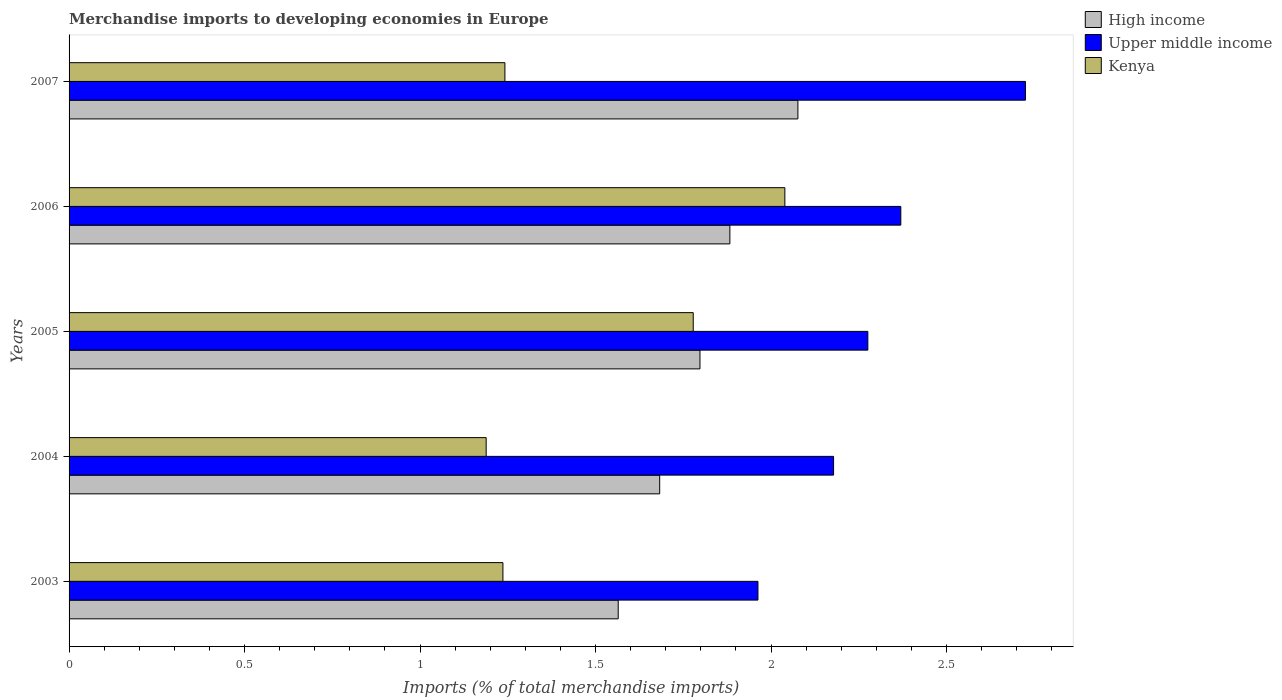How many groups of bars are there?
Offer a terse response. 5. What is the label of the 2nd group of bars from the top?
Your answer should be compact. 2006. In how many cases, is the number of bars for a given year not equal to the number of legend labels?
Make the answer very short. 0. What is the percentage total merchandise imports in Upper middle income in 2005?
Provide a short and direct response. 2.28. Across all years, what is the maximum percentage total merchandise imports in Kenya?
Your response must be concise. 2.04. Across all years, what is the minimum percentage total merchandise imports in Kenya?
Give a very brief answer. 1.19. What is the total percentage total merchandise imports in Kenya in the graph?
Your answer should be very brief. 7.48. What is the difference between the percentage total merchandise imports in Upper middle income in 2003 and that in 2004?
Your answer should be very brief. -0.22. What is the difference between the percentage total merchandise imports in High income in 2005 and the percentage total merchandise imports in Upper middle income in 2003?
Your response must be concise. -0.17. What is the average percentage total merchandise imports in Upper middle income per year?
Provide a short and direct response. 2.3. In the year 2006, what is the difference between the percentage total merchandise imports in Kenya and percentage total merchandise imports in Upper middle income?
Keep it short and to the point. -0.33. What is the ratio of the percentage total merchandise imports in Kenya in 2003 to that in 2004?
Make the answer very short. 1.04. What is the difference between the highest and the second highest percentage total merchandise imports in Upper middle income?
Provide a short and direct response. 0.36. What is the difference between the highest and the lowest percentage total merchandise imports in High income?
Make the answer very short. 0.51. In how many years, is the percentage total merchandise imports in Upper middle income greater than the average percentage total merchandise imports in Upper middle income taken over all years?
Offer a terse response. 2. Is the sum of the percentage total merchandise imports in Kenya in 2004 and 2007 greater than the maximum percentage total merchandise imports in Upper middle income across all years?
Provide a succinct answer. No. What does the 2nd bar from the bottom in 2003 represents?
Offer a terse response. Upper middle income. How many bars are there?
Offer a terse response. 15. How many years are there in the graph?
Your response must be concise. 5. Are the values on the major ticks of X-axis written in scientific E-notation?
Offer a terse response. No. Where does the legend appear in the graph?
Offer a very short reply. Top right. How many legend labels are there?
Keep it short and to the point. 3. How are the legend labels stacked?
Ensure brevity in your answer.  Vertical. What is the title of the graph?
Ensure brevity in your answer.  Merchandise imports to developing economies in Europe. What is the label or title of the X-axis?
Provide a short and direct response. Imports (% of total merchandise imports). What is the label or title of the Y-axis?
Make the answer very short. Years. What is the Imports (% of total merchandise imports) in High income in 2003?
Your response must be concise. 1.56. What is the Imports (% of total merchandise imports) of Upper middle income in 2003?
Your answer should be compact. 1.96. What is the Imports (% of total merchandise imports) in Kenya in 2003?
Provide a succinct answer. 1.24. What is the Imports (% of total merchandise imports) in High income in 2004?
Offer a very short reply. 1.68. What is the Imports (% of total merchandise imports) of Upper middle income in 2004?
Ensure brevity in your answer.  2.18. What is the Imports (% of total merchandise imports) of Kenya in 2004?
Provide a succinct answer. 1.19. What is the Imports (% of total merchandise imports) in High income in 2005?
Offer a terse response. 1.8. What is the Imports (% of total merchandise imports) in Upper middle income in 2005?
Your answer should be compact. 2.28. What is the Imports (% of total merchandise imports) of Kenya in 2005?
Keep it short and to the point. 1.78. What is the Imports (% of total merchandise imports) in High income in 2006?
Your answer should be very brief. 1.88. What is the Imports (% of total merchandise imports) in Upper middle income in 2006?
Provide a succinct answer. 2.37. What is the Imports (% of total merchandise imports) of Kenya in 2006?
Provide a succinct answer. 2.04. What is the Imports (% of total merchandise imports) of High income in 2007?
Your answer should be very brief. 2.08. What is the Imports (% of total merchandise imports) of Upper middle income in 2007?
Make the answer very short. 2.72. What is the Imports (% of total merchandise imports) of Kenya in 2007?
Keep it short and to the point. 1.24. Across all years, what is the maximum Imports (% of total merchandise imports) of High income?
Offer a terse response. 2.08. Across all years, what is the maximum Imports (% of total merchandise imports) of Upper middle income?
Offer a very short reply. 2.72. Across all years, what is the maximum Imports (% of total merchandise imports) of Kenya?
Make the answer very short. 2.04. Across all years, what is the minimum Imports (% of total merchandise imports) in High income?
Provide a short and direct response. 1.56. Across all years, what is the minimum Imports (% of total merchandise imports) of Upper middle income?
Offer a terse response. 1.96. Across all years, what is the minimum Imports (% of total merchandise imports) in Kenya?
Make the answer very short. 1.19. What is the total Imports (% of total merchandise imports) in High income in the graph?
Keep it short and to the point. 9. What is the total Imports (% of total merchandise imports) in Upper middle income in the graph?
Your answer should be compact. 11.51. What is the total Imports (% of total merchandise imports) in Kenya in the graph?
Offer a terse response. 7.48. What is the difference between the Imports (% of total merchandise imports) of High income in 2003 and that in 2004?
Your answer should be compact. -0.12. What is the difference between the Imports (% of total merchandise imports) in Upper middle income in 2003 and that in 2004?
Provide a short and direct response. -0.22. What is the difference between the Imports (% of total merchandise imports) in Kenya in 2003 and that in 2004?
Offer a very short reply. 0.05. What is the difference between the Imports (% of total merchandise imports) of High income in 2003 and that in 2005?
Your response must be concise. -0.23. What is the difference between the Imports (% of total merchandise imports) of Upper middle income in 2003 and that in 2005?
Offer a very short reply. -0.31. What is the difference between the Imports (% of total merchandise imports) in Kenya in 2003 and that in 2005?
Keep it short and to the point. -0.54. What is the difference between the Imports (% of total merchandise imports) in High income in 2003 and that in 2006?
Offer a very short reply. -0.32. What is the difference between the Imports (% of total merchandise imports) in Upper middle income in 2003 and that in 2006?
Your response must be concise. -0.41. What is the difference between the Imports (% of total merchandise imports) of Kenya in 2003 and that in 2006?
Your answer should be compact. -0.8. What is the difference between the Imports (% of total merchandise imports) of High income in 2003 and that in 2007?
Offer a very short reply. -0.51. What is the difference between the Imports (% of total merchandise imports) of Upper middle income in 2003 and that in 2007?
Provide a short and direct response. -0.76. What is the difference between the Imports (% of total merchandise imports) of Kenya in 2003 and that in 2007?
Keep it short and to the point. -0.01. What is the difference between the Imports (% of total merchandise imports) in High income in 2004 and that in 2005?
Your response must be concise. -0.11. What is the difference between the Imports (% of total merchandise imports) of Upper middle income in 2004 and that in 2005?
Offer a terse response. -0.1. What is the difference between the Imports (% of total merchandise imports) of Kenya in 2004 and that in 2005?
Give a very brief answer. -0.59. What is the difference between the Imports (% of total merchandise imports) in High income in 2004 and that in 2006?
Provide a succinct answer. -0.2. What is the difference between the Imports (% of total merchandise imports) of Upper middle income in 2004 and that in 2006?
Your answer should be very brief. -0.19. What is the difference between the Imports (% of total merchandise imports) of Kenya in 2004 and that in 2006?
Your answer should be very brief. -0.85. What is the difference between the Imports (% of total merchandise imports) in High income in 2004 and that in 2007?
Provide a short and direct response. -0.39. What is the difference between the Imports (% of total merchandise imports) in Upper middle income in 2004 and that in 2007?
Offer a very short reply. -0.55. What is the difference between the Imports (% of total merchandise imports) of Kenya in 2004 and that in 2007?
Make the answer very short. -0.05. What is the difference between the Imports (% of total merchandise imports) of High income in 2005 and that in 2006?
Your response must be concise. -0.09. What is the difference between the Imports (% of total merchandise imports) in Upper middle income in 2005 and that in 2006?
Your answer should be compact. -0.09. What is the difference between the Imports (% of total merchandise imports) in Kenya in 2005 and that in 2006?
Offer a terse response. -0.26. What is the difference between the Imports (% of total merchandise imports) in High income in 2005 and that in 2007?
Ensure brevity in your answer.  -0.28. What is the difference between the Imports (% of total merchandise imports) in Upper middle income in 2005 and that in 2007?
Make the answer very short. -0.45. What is the difference between the Imports (% of total merchandise imports) of Kenya in 2005 and that in 2007?
Provide a succinct answer. 0.54. What is the difference between the Imports (% of total merchandise imports) in High income in 2006 and that in 2007?
Ensure brevity in your answer.  -0.19. What is the difference between the Imports (% of total merchandise imports) in Upper middle income in 2006 and that in 2007?
Your answer should be very brief. -0.36. What is the difference between the Imports (% of total merchandise imports) of Kenya in 2006 and that in 2007?
Give a very brief answer. 0.8. What is the difference between the Imports (% of total merchandise imports) of High income in 2003 and the Imports (% of total merchandise imports) of Upper middle income in 2004?
Make the answer very short. -0.61. What is the difference between the Imports (% of total merchandise imports) in High income in 2003 and the Imports (% of total merchandise imports) in Kenya in 2004?
Make the answer very short. 0.38. What is the difference between the Imports (% of total merchandise imports) in Upper middle income in 2003 and the Imports (% of total merchandise imports) in Kenya in 2004?
Your answer should be compact. 0.77. What is the difference between the Imports (% of total merchandise imports) in High income in 2003 and the Imports (% of total merchandise imports) in Upper middle income in 2005?
Offer a terse response. -0.71. What is the difference between the Imports (% of total merchandise imports) in High income in 2003 and the Imports (% of total merchandise imports) in Kenya in 2005?
Keep it short and to the point. -0.21. What is the difference between the Imports (% of total merchandise imports) of Upper middle income in 2003 and the Imports (% of total merchandise imports) of Kenya in 2005?
Provide a short and direct response. 0.18. What is the difference between the Imports (% of total merchandise imports) of High income in 2003 and the Imports (% of total merchandise imports) of Upper middle income in 2006?
Give a very brief answer. -0.81. What is the difference between the Imports (% of total merchandise imports) of High income in 2003 and the Imports (% of total merchandise imports) of Kenya in 2006?
Your answer should be very brief. -0.47. What is the difference between the Imports (% of total merchandise imports) in Upper middle income in 2003 and the Imports (% of total merchandise imports) in Kenya in 2006?
Your answer should be compact. -0.08. What is the difference between the Imports (% of total merchandise imports) of High income in 2003 and the Imports (% of total merchandise imports) of Upper middle income in 2007?
Your answer should be compact. -1.16. What is the difference between the Imports (% of total merchandise imports) of High income in 2003 and the Imports (% of total merchandise imports) of Kenya in 2007?
Ensure brevity in your answer.  0.32. What is the difference between the Imports (% of total merchandise imports) of Upper middle income in 2003 and the Imports (% of total merchandise imports) of Kenya in 2007?
Provide a short and direct response. 0.72. What is the difference between the Imports (% of total merchandise imports) in High income in 2004 and the Imports (% of total merchandise imports) in Upper middle income in 2005?
Make the answer very short. -0.59. What is the difference between the Imports (% of total merchandise imports) in High income in 2004 and the Imports (% of total merchandise imports) in Kenya in 2005?
Your answer should be very brief. -0.1. What is the difference between the Imports (% of total merchandise imports) in Upper middle income in 2004 and the Imports (% of total merchandise imports) in Kenya in 2005?
Provide a succinct answer. 0.4. What is the difference between the Imports (% of total merchandise imports) of High income in 2004 and the Imports (% of total merchandise imports) of Upper middle income in 2006?
Keep it short and to the point. -0.69. What is the difference between the Imports (% of total merchandise imports) of High income in 2004 and the Imports (% of total merchandise imports) of Kenya in 2006?
Offer a terse response. -0.36. What is the difference between the Imports (% of total merchandise imports) of Upper middle income in 2004 and the Imports (% of total merchandise imports) of Kenya in 2006?
Give a very brief answer. 0.14. What is the difference between the Imports (% of total merchandise imports) in High income in 2004 and the Imports (% of total merchandise imports) in Upper middle income in 2007?
Keep it short and to the point. -1.04. What is the difference between the Imports (% of total merchandise imports) of High income in 2004 and the Imports (% of total merchandise imports) of Kenya in 2007?
Offer a terse response. 0.44. What is the difference between the Imports (% of total merchandise imports) in Upper middle income in 2004 and the Imports (% of total merchandise imports) in Kenya in 2007?
Your answer should be compact. 0.94. What is the difference between the Imports (% of total merchandise imports) of High income in 2005 and the Imports (% of total merchandise imports) of Upper middle income in 2006?
Your answer should be very brief. -0.57. What is the difference between the Imports (% of total merchandise imports) in High income in 2005 and the Imports (% of total merchandise imports) in Kenya in 2006?
Offer a terse response. -0.24. What is the difference between the Imports (% of total merchandise imports) of Upper middle income in 2005 and the Imports (% of total merchandise imports) of Kenya in 2006?
Make the answer very short. 0.24. What is the difference between the Imports (% of total merchandise imports) of High income in 2005 and the Imports (% of total merchandise imports) of Upper middle income in 2007?
Offer a terse response. -0.93. What is the difference between the Imports (% of total merchandise imports) in High income in 2005 and the Imports (% of total merchandise imports) in Kenya in 2007?
Ensure brevity in your answer.  0.56. What is the difference between the Imports (% of total merchandise imports) of Upper middle income in 2005 and the Imports (% of total merchandise imports) of Kenya in 2007?
Offer a very short reply. 1.03. What is the difference between the Imports (% of total merchandise imports) of High income in 2006 and the Imports (% of total merchandise imports) of Upper middle income in 2007?
Offer a terse response. -0.84. What is the difference between the Imports (% of total merchandise imports) in High income in 2006 and the Imports (% of total merchandise imports) in Kenya in 2007?
Give a very brief answer. 0.64. What is the difference between the Imports (% of total merchandise imports) in Upper middle income in 2006 and the Imports (% of total merchandise imports) in Kenya in 2007?
Keep it short and to the point. 1.13. What is the average Imports (% of total merchandise imports) of High income per year?
Provide a succinct answer. 1.8. What is the average Imports (% of total merchandise imports) of Upper middle income per year?
Give a very brief answer. 2.3. What is the average Imports (% of total merchandise imports) of Kenya per year?
Your response must be concise. 1.5. In the year 2003, what is the difference between the Imports (% of total merchandise imports) of High income and Imports (% of total merchandise imports) of Upper middle income?
Your answer should be very brief. -0.4. In the year 2003, what is the difference between the Imports (% of total merchandise imports) in High income and Imports (% of total merchandise imports) in Kenya?
Offer a terse response. 0.33. In the year 2003, what is the difference between the Imports (% of total merchandise imports) in Upper middle income and Imports (% of total merchandise imports) in Kenya?
Provide a succinct answer. 0.73. In the year 2004, what is the difference between the Imports (% of total merchandise imports) of High income and Imports (% of total merchandise imports) of Upper middle income?
Keep it short and to the point. -0.5. In the year 2004, what is the difference between the Imports (% of total merchandise imports) in High income and Imports (% of total merchandise imports) in Kenya?
Your answer should be compact. 0.49. In the year 2005, what is the difference between the Imports (% of total merchandise imports) of High income and Imports (% of total merchandise imports) of Upper middle income?
Your answer should be very brief. -0.48. In the year 2005, what is the difference between the Imports (% of total merchandise imports) in High income and Imports (% of total merchandise imports) in Kenya?
Offer a terse response. 0.02. In the year 2005, what is the difference between the Imports (% of total merchandise imports) of Upper middle income and Imports (% of total merchandise imports) of Kenya?
Provide a succinct answer. 0.5. In the year 2006, what is the difference between the Imports (% of total merchandise imports) of High income and Imports (% of total merchandise imports) of Upper middle income?
Keep it short and to the point. -0.49. In the year 2006, what is the difference between the Imports (% of total merchandise imports) of High income and Imports (% of total merchandise imports) of Kenya?
Ensure brevity in your answer.  -0.16. In the year 2006, what is the difference between the Imports (% of total merchandise imports) of Upper middle income and Imports (% of total merchandise imports) of Kenya?
Ensure brevity in your answer.  0.33. In the year 2007, what is the difference between the Imports (% of total merchandise imports) in High income and Imports (% of total merchandise imports) in Upper middle income?
Provide a short and direct response. -0.65. In the year 2007, what is the difference between the Imports (% of total merchandise imports) in High income and Imports (% of total merchandise imports) in Kenya?
Offer a very short reply. 0.83. In the year 2007, what is the difference between the Imports (% of total merchandise imports) in Upper middle income and Imports (% of total merchandise imports) in Kenya?
Offer a very short reply. 1.48. What is the ratio of the Imports (% of total merchandise imports) of High income in 2003 to that in 2004?
Your response must be concise. 0.93. What is the ratio of the Imports (% of total merchandise imports) in Upper middle income in 2003 to that in 2004?
Your answer should be very brief. 0.9. What is the ratio of the Imports (% of total merchandise imports) in Kenya in 2003 to that in 2004?
Give a very brief answer. 1.04. What is the ratio of the Imports (% of total merchandise imports) in High income in 2003 to that in 2005?
Your answer should be very brief. 0.87. What is the ratio of the Imports (% of total merchandise imports) in Upper middle income in 2003 to that in 2005?
Make the answer very short. 0.86. What is the ratio of the Imports (% of total merchandise imports) in Kenya in 2003 to that in 2005?
Offer a terse response. 0.7. What is the ratio of the Imports (% of total merchandise imports) of High income in 2003 to that in 2006?
Keep it short and to the point. 0.83. What is the ratio of the Imports (% of total merchandise imports) of Upper middle income in 2003 to that in 2006?
Offer a very short reply. 0.83. What is the ratio of the Imports (% of total merchandise imports) in Kenya in 2003 to that in 2006?
Offer a very short reply. 0.61. What is the ratio of the Imports (% of total merchandise imports) in High income in 2003 to that in 2007?
Offer a terse response. 0.75. What is the ratio of the Imports (% of total merchandise imports) in Upper middle income in 2003 to that in 2007?
Your response must be concise. 0.72. What is the ratio of the Imports (% of total merchandise imports) in Kenya in 2003 to that in 2007?
Offer a terse response. 1. What is the ratio of the Imports (% of total merchandise imports) in High income in 2004 to that in 2005?
Keep it short and to the point. 0.94. What is the ratio of the Imports (% of total merchandise imports) of Upper middle income in 2004 to that in 2005?
Your answer should be very brief. 0.96. What is the ratio of the Imports (% of total merchandise imports) in Kenya in 2004 to that in 2005?
Keep it short and to the point. 0.67. What is the ratio of the Imports (% of total merchandise imports) of High income in 2004 to that in 2006?
Provide a short and direct response. 0.89. What is the ratio of the Imports (% of total merchandise imports) in Upper middle income in 2004 to that in 2006?
Make the answer very short. 0.92. What is the ratio of the Imports (% of total merchandise imports) of Kenya in 2004 to that in 2006?
Provide a succinct answer. 0.58. What is the ratio of the Imports (% of total merchandise imports) in High income in 2004 to that in 2007?
Ensure brevity in your answer.  0.81. What is the ratio of the Imports (% of total merchandise imports) of Upper middle income in 2004 to that in 2007?
Your response must be concise. 0.8. What is the ratio of the Imports (% of total merchandise imports) in Kenya in 2004 to that in 2007?
Offer a very short reply. 0.96. What is the ratio of the Imports (% of total merchandise imports) of High income in 2005 to that in 2006?
Your answer should be very brief. 0.95. What is the ratio of the Imports (% of total merchandise imports) of Upper middle income in 2005 to that in 2006?
Offer a terse response. 0.96. What is the ratio of the Imports (% of total merchandise imports) of Kenya in 2005 to that in 2006?
Give a very brief answer. 0.87. What is the ratio of the Imports (% of total merchandise imports) of High income in 2005 to that in 2007?
Your answer should be very brief. 0.87. What is the ratio of the Imports (% of total merchandise imports) of Upper middle income in 2005 to that in 2007?
Your response must be concise. 0.84. What is the ratio of the Imports (% of total merchandise imports) in Kenya in 2005 to that in 2007?
Your response must be concise. 1.43. What is the ratio of the Imports (% of total merchandise imports) in High income in 2006 to that in 2007?
Provide a short and direct response. 0.91. What is the ratio of the Imports (% of total merchandise imports) in Upper middle income in 2006 to that in 2007?
Offer a terse response. 0.87. What is the ratio of the Imports (% of total merchandise imports) of Kenya in 2006 to that in 2007?
Your response must be concise. 1.64. What is the difference between the highest and the second highest Imports (% of total merchandise imports) of High income?
Provide a succinct answer. 0.19. What is the difference between the highest and the second highest Imports (% of total merchandise imports) of Upper middle income?
Make the answer very short. 0.36. What is the difference between the highest and the second highest Imports (% of total merchandise imports) of Kenya?
Provide a short and direct response. 0.26. What is the difference between the highest and the lowest Imports (% of total merchandise imports) in High income?
Your answer should be compact. 0.51. What is the difference between the highest and the lowest Imports (% of total merchandise imports) in Upper middle income?
Offer a very short reply. 0.76. What is the difference between the highest and the lowest Imports (% of total merchandise imports) of Kenya?
Your answer should be compact. 0.85. 